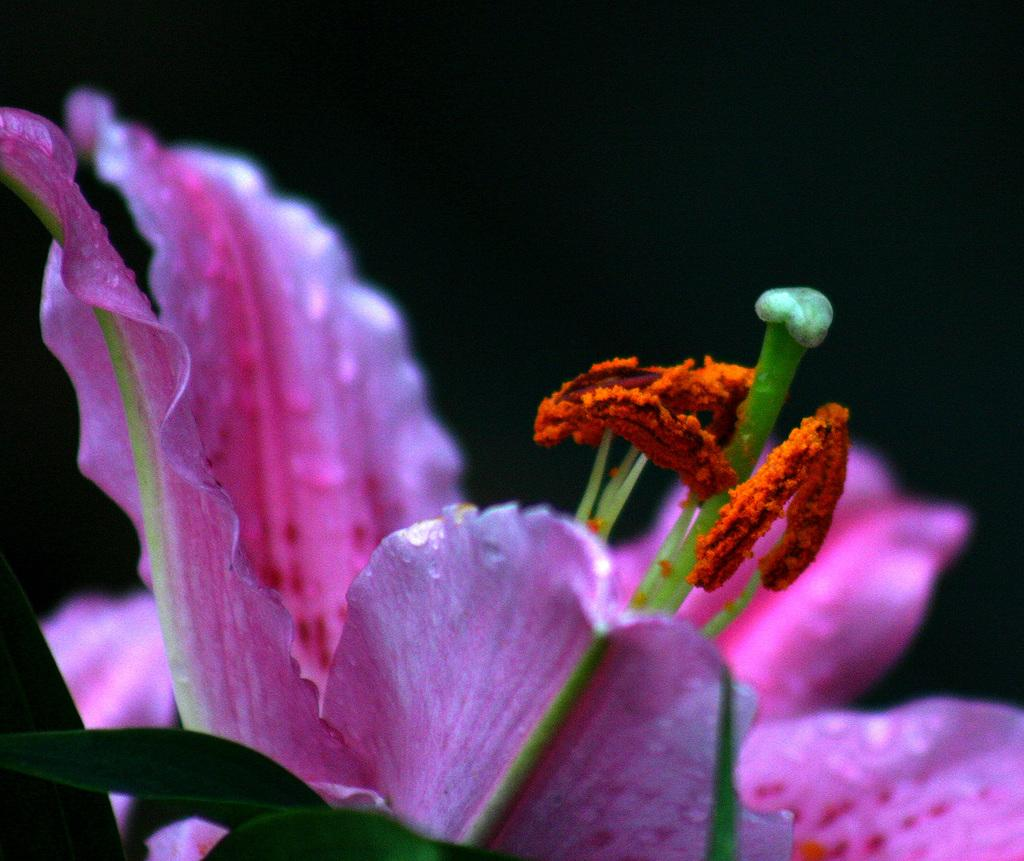What type of flower is in the image? There is a pink flower in the image. How many leaves does the flower have? The flower has two leaves. What is the color of the background in the image? The background of the image is dark. What type of quilt is covering the flower in the image? There is no quilt present in the image; it features a pink flower with two leaves against a dark background. 